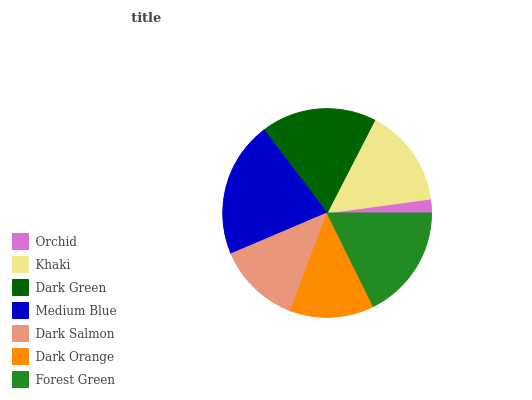Is Orchid the minimum?
Answer yes or no. Yes. Is Medium Blue the maximum?
Answer yes or no. Yes. Is Khaki the minimum?
Answer yes or no. No. Is Khaki the maximum?
Answer yes or no. No. Is Khaki greater than Orchid?
Answer yes or no. Yes. Is Orchid less than Khaki?
Answer yes or no. Yes. Is Orchid greater than Khaki?
Answer yes or no. No. Is Khaki less than Orchid?
Answer yes or no. No. Is Khaki the high median?
Answer yes or no. Yes. Is Khaki the low median?
Answer yes or no. Yes. Is Dark Salmon the high median?
Answer yes or no. No. Is Dark Green the low median?
Answer yes or no. No. 